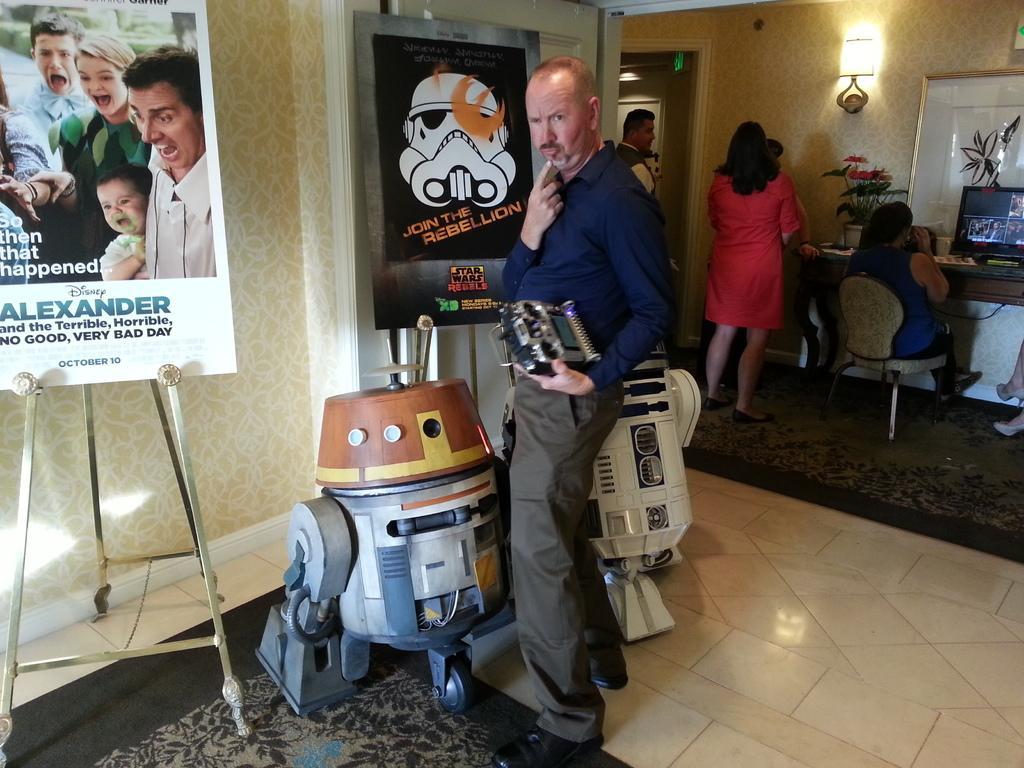Could you give a brief overview of what you see in this image? This image is clicked in a room. At the bottom, there is floor. In the front, there is a man standing and holding a remote. To the left, there is a board kept on the stand. In the background, there are many people sitting in the chairs. 